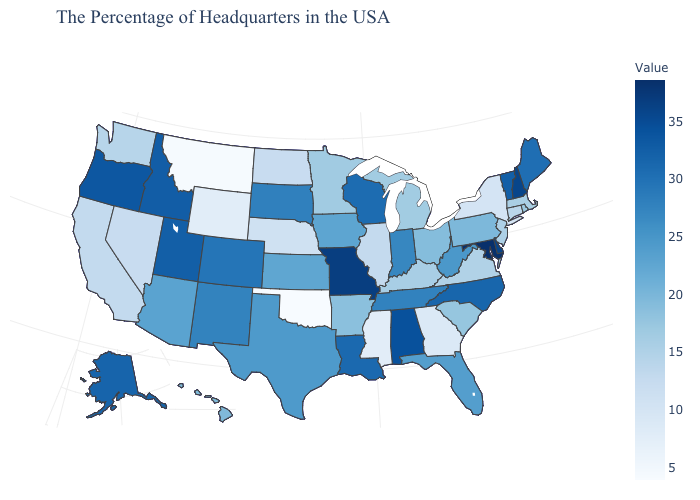Does Kansas have a lower value than Louisiana?
Write a very short answer. Yes. Does the map have missing data?
Keep it brief. No. Does Oklahoma have the lowest value in the South?
Give a very brief answer. Yes. Does the map have missing data?
Keep it brief. No. Among the states that border New Hampshire , does Vermont have the lowest value?
Keep it brief. No. 